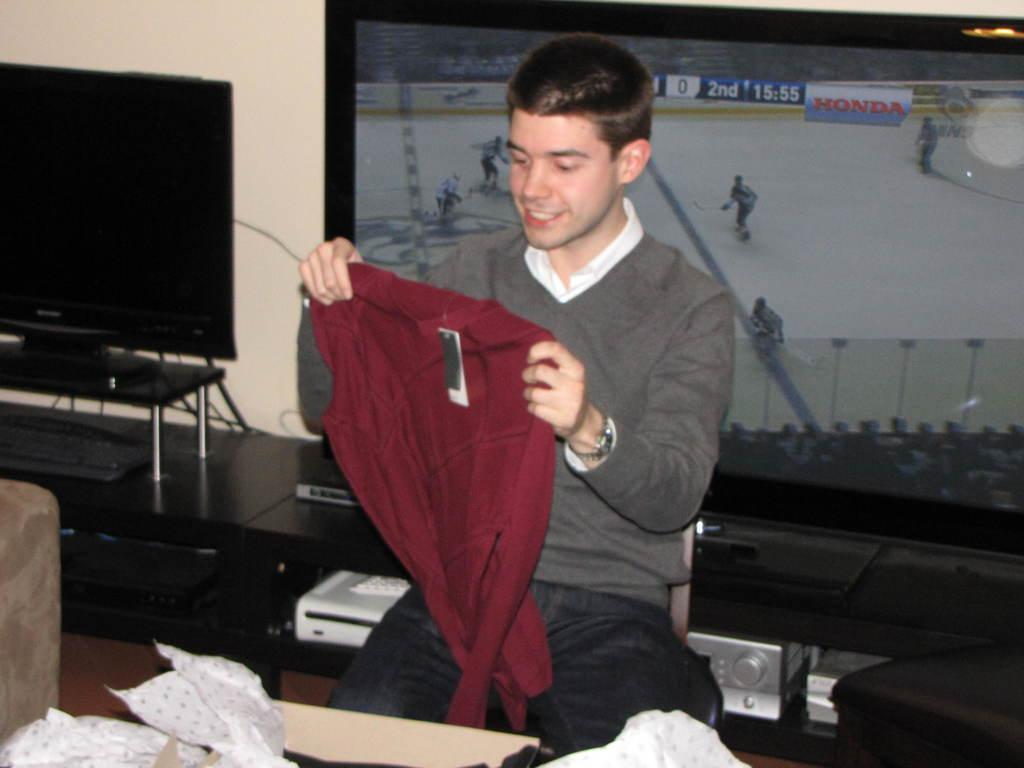<image>
Offer a succinct explanation of the picture presented. The hockey broadcast on the television has Honda as a sponsor. 